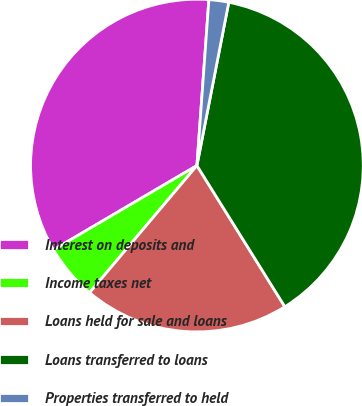Convert chart to OTSL. <chart><loc_0><loc_0><loc_500><loc_500><pie_chart><fcel>Interest on deposits and<fcel>Income taxes net<fcel>Loans held for sale and loans<fcel>Loans transferred to loans<fcel>Properties transferred to held<nl><fcel>34.6%<fcel>5.39%<fcel>20.03%<fcel>38.07%<fcel>1.92%<nl></chart> 